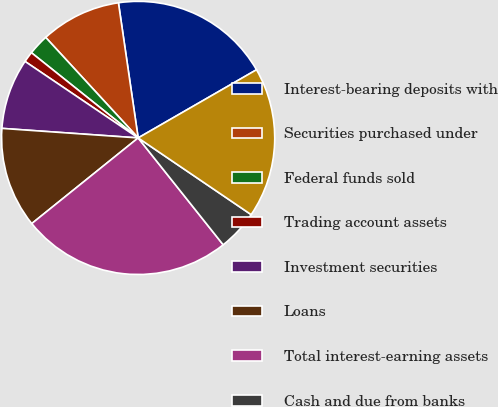<chart> <loc_0><loc_0><loc_500><loc_500><pie_chart><fcel>Interest-bearing deposits with<fcel>Securities purchased under<fcel>Federal funds sold<fcel>Trading account assets<fcel>Investment securities<fcel>Loans<fcel>Total interest-earning assets<fcel>Cash and due from banks<fcel>Other assets<nl><fcel>18.99%<fcel>9.53%<fcel>2.44%<fcel>1.26%<fcel>8.35%<fcel>11.9%<fcel>24.91%<fcel>4.81%<fcel>17.81%<nl></chart> 